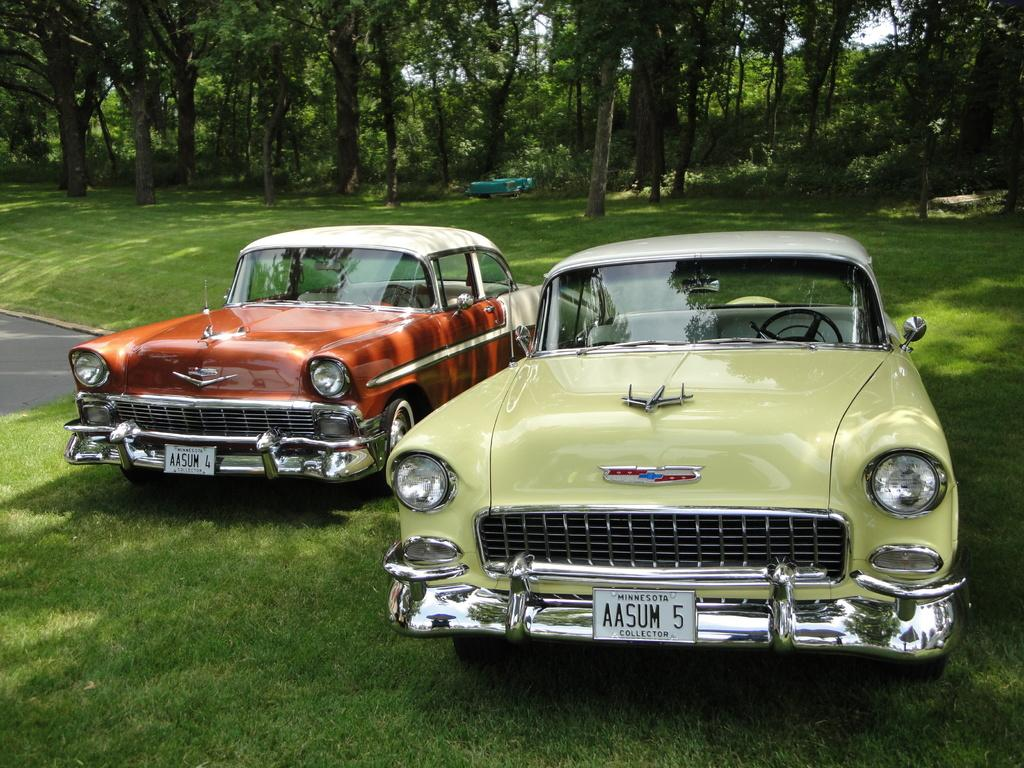How many cars are present in the image? There are two cars in the image. Where are the cars located? The cars are on the surface of the grass. What can be seen in the background of the image? There are trees and sky visible in the background of the image. What is in the center of the image? There is an unspecified object in the center of the image. What type of support can be seen holding up the cakes in the image? There are no cakes or any type of support present in the image. 